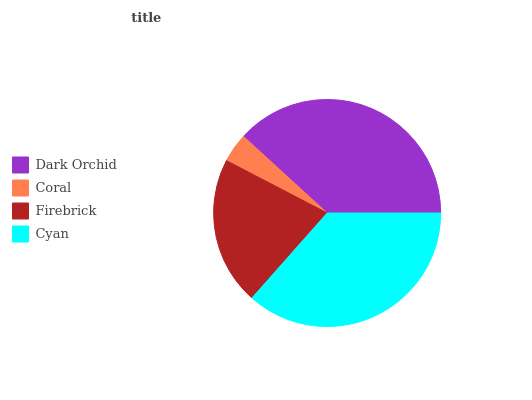Is Coral the minimum?
Answer yes or no. Yes. Is Dark Orchid the maximum?
Answer yes or no. Yes. Is Firebrick the minimum?
Answer yes or no. No. Is Firebrick the maximum?
Answer yes or no. No. Is Firebrick greater than Coral?
Answer yes or no. Yes. Is Coral less than Firebrick?
Answer yes or no. Yes. Is Coral greater than Firebrick?
Answer yes or no. No. Is Firebrick less than Coral?
Answer yes or no. No. Is Cyan the high median?
Answer yes or no. Yes. Is Firebrick the low median?
Answer yes or no. Yes. Is Firebrick the high median?
Answer yes or no. No. Is Coral the low median?
Answer yes or no. No. 